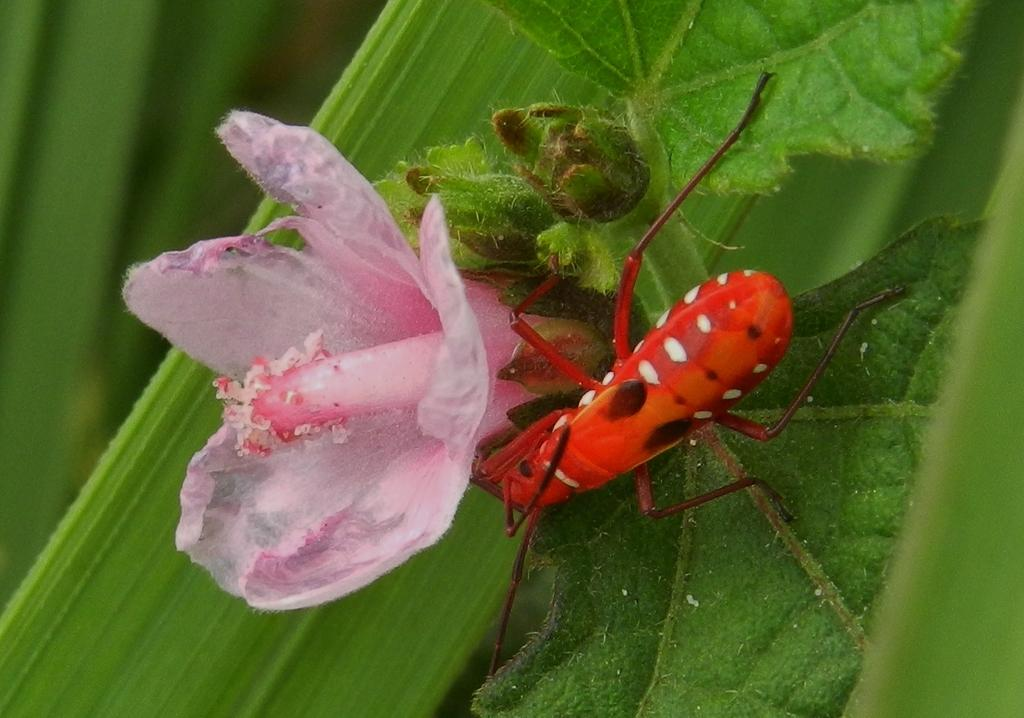What type of vegetation can be seen in the image? There is grass in the image. Are there any other plants visible in the image? Yes, there is a flower in the image. What else can be found on the grass in the image? There is an insect on the grass in the image. What type of chair is visible in the image? There is no chair present in the image. Can you describe the building that is shown in the image? There is no building shown in the image; it features grass, a flower, and an insect. 